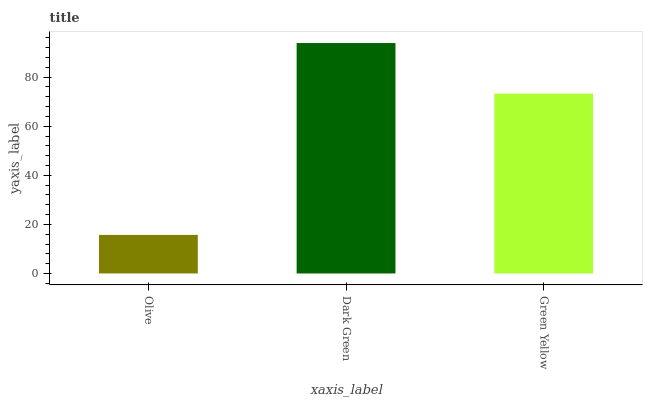Is Olive the minimum?
Answer yes or no. Yes. Is Dark Green the maximum?
Answer yes or no. Yes. Is Green Yellow the minimum?
Answer yes or no. No. Is Green Yellow the maximum?
Answer yes or no. No. Is Dark Green greater than Green Yellow?
Answer yes or no. Yes. Is Green Yellow less than Dark Green?
Answer yes or no. Yes. Is Green Yellow greater than Dark Green?
Answer yes or no. No. Is Dark Green less than Green Yellow?
Answer yes or no. No. Is Green Yellow the high median?
Answer yes or no. Yes. Is Green Yellow the low median?
Answer yes or no. Yes. Is Olive the high median?
Answer yes or no. No. Is Dark Green the low median?
Answer yes or no. No. 